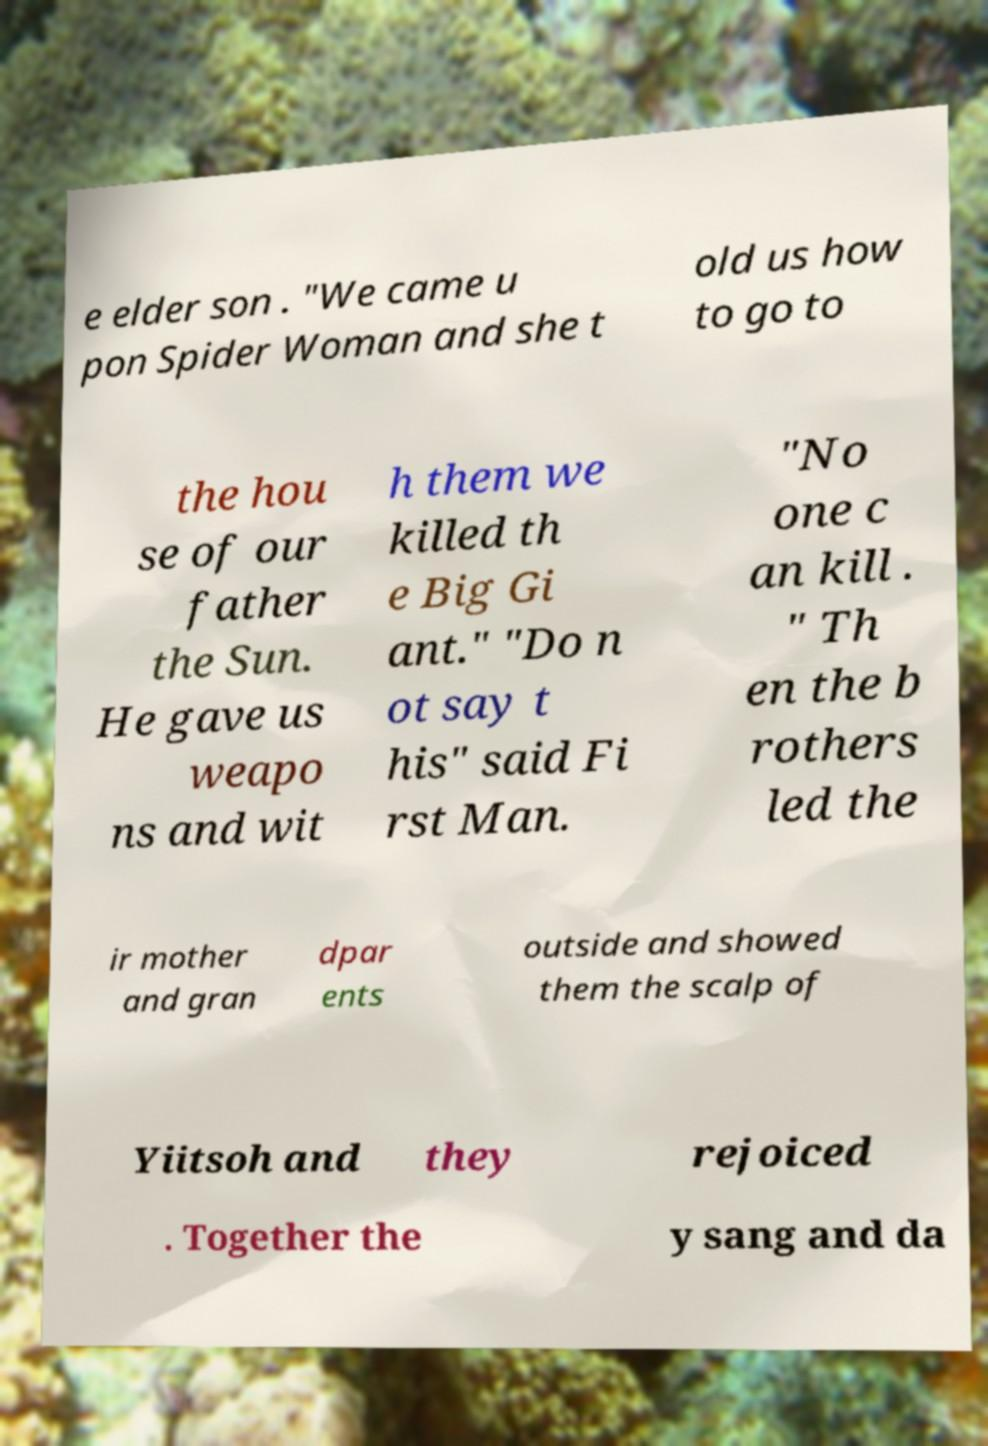Could you assist in decoding the text presented in this image and type it out clearly? e elder son . "We came u pon Spider Woman and she t old us how to go to the hou se of our father the Sun. He gave us weapo ns and wit h them we killed th e Big Gi ant." "Do n ot say t his" said Fi rst Man. "No one c an kill . " Th en the b rothers led the ir mother and gran dpar ents outside and showed them the scalp of Yiitsoh and they rejoiced . Together the y sang and da 